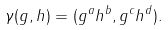<formula> <loc_0><loc_0><loc_500><loc_500>\gamma ( g , h ) = ( g ^ { a } h ^ { b } , g ^ { c } h ^ { d } ) .</formula> 